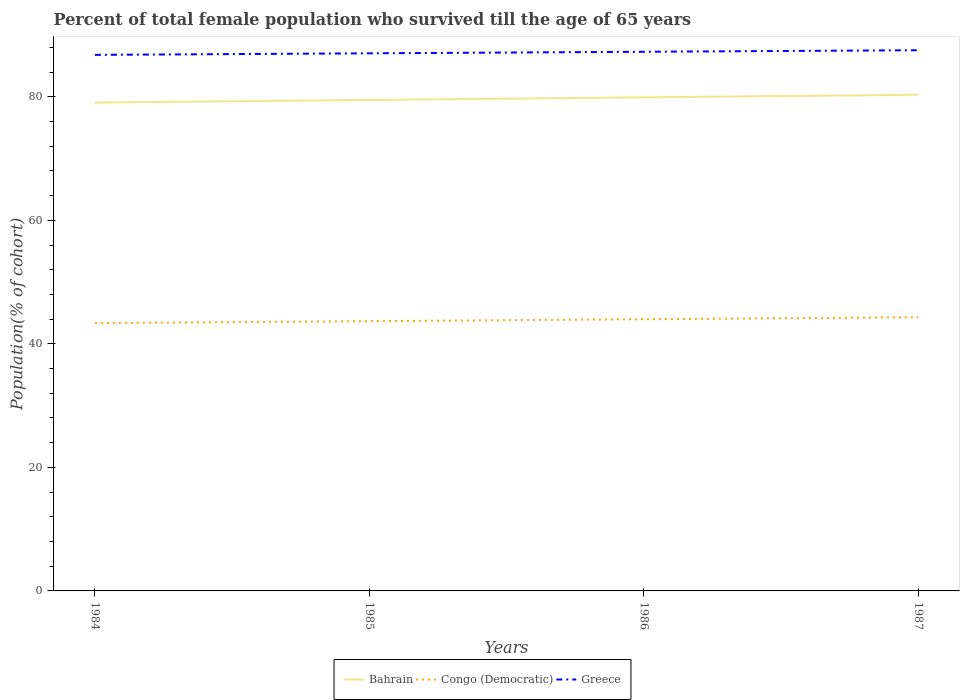How many different coloured lines are there?
Your response must be concise. 3. Is the number of lines equal to the number of legend labels?
Your answer should be very brief. Yes. Across all years, what is the maximum percentage of total female population who survived till the age of 65 years in Congo (Democratic)?
Provide a short and direct response. 43.37. What is the total percentage of total female population who survived till the age of 65 years in Bahrain in the graph?
Your answer should be very brief. -0.85. What is the difference between the highest and the second highest percentage of total female population who survived till the age of 65 years in Bahrain?
Your answer should be compact. 1.27. What is the difference between the highest and the lowest percentage of total female population who survived till the age of 65 years in Bahrain?
Ensure brevity in your answer.  2. What is the difference between two consecutive major ticks on the Y-axis?
Make the answer very short. 20. Does the graph contain any zero values?
Your answer should be compact. No. Where does the legend appear in the graph?
Offer a terse response. Bottom center. What is the title of the graph?
Keep it short and to the point. Percent of total female population who survived till the age of 65 years. What is the label or title of the Y-axis?
Offer a terse response. Population(% of cohort). What is the Population(% of cohort) in Bahrain in 1984?
Your response must be concise. 79.07. What is the Population(% of cohort) in Congo (Democratic) in 1984?
Ensure brevity in your answer.  43.37. What is the Population(% of cohort) in Greece in 1984?
Make the answer very short. 86.8. What is the Population(% of cohort) in Bahrain in 1985?
Offer a very short reply. 79.5. What is the Population(% of cohort) of Congo (Democratic) in 1985?
Your answer should be very brief. 43.68. What is the Population(% of cohort) in Greece in 1985?
Ensure brevity in your answer.  87.05. What is the Population(% of cohort) in Bahrain in 1986?
Your answer should be very brief. 79.92. What is the Population(% of cohort) of Congo (Democratic) in 1986?
Your answer should be compact. 44. What is the Population(% of cohort) of Greece in 1986?
Your response must be concise. 87.3. What is the Population(% of cohort) of Bahrain in 1987?
Offer a terse response. 80.34. What is the Population(% of cohort) in Congo (Democratic) in 1987?
Provide a short and direct response. 44.31. What is the Population(% of cohort) in Greece in 1987?
Your answer should be compact. 87.55. Across all years, what is the maximum Population(% of cohort) in Bahrain?
Give a very brief answer. 80.34. Across all years, what is the maximum Population(% of cohort) in Congo (Democratic)?
Provide a succinct answer. 44.31. Across all years, what is the maximum Population(% of cohort) of Greece?
Offer a terse response. 87.55. Across all years, what is the minimum Population(% of cohort) in Bahrain?
Provide a short and direct response. 79.07. Across all years, what is the minimum Population(% of cohort) of Congo (Democratic)?
Provide a succinct answer. 43.37. Across all years, what is the minimum Population(% of cohort) in Greece?
Your answer should be very brief. 86.8. What is the total Population(% of cohort) of Bahrain in the graph?
Your response must be concise. 318.84. What is the total Population(% of cohort) of Congo (Democratic) in the graph?
Keep it short and to the point. 175.35. What is the total Population(% of cohort) of Greece in the graph?
Your answer should be compact. 348.7. What is the difference between the Population(% of cohort) of Bahrain in 1984 and that in 1985?
Offer a very short reply. -0.42. What is the difference between the Population(% of cohort) of Congo (Democratic) in 1984 and that in 1985?
Your answer should be very brief. -0.32. What is the difference between the Population(% of cohort) of Greece in 1984 and that in 1985?
Provide a short and direct response. -0.25. What is the difference between the Population(% of cohort) in Bahrain in 1984 and that in 1986?
Give a very brief answer. -0.85. What is the difference between the Population(% of cohort) in Congo (Democratic) in 1984 and that in 1986?
Keep it short and to the point. -0.63. What is the difference between the Population(% of cohort) of Greece in 1984 and that in 1986?
Ensure brevity in your answer.  -0.5. What is the difference between the Population(% of cohort) in Bahrain in 1984 and that in 1987?
Keep it short and to the point. -1.27. What is the difference between the Population(% of cohort) in Congo (Democratic) in 1984 and that in 1987?
Keep it short and to the point. -0.95. What is the difference between the Population(% of cohort) in Greece in 1984 and that in 1987?
Your response must be concise. -0.75. What is the difference between the Population(% of cohort) of Bahrain in 1985 and that in 1986?
Make the answer very short. -0.42. What is the difference between the Population(% of cohort) in Congo (Democratic) in 1985 and that in 1986?
Offer a terse response. -0.32. What is the difference between the Population(% of cohort) in Greece in 1985 and that in 1986?
Provide a short and direct response. -0.25. What is the difference between the Population(% of cohort) in Bahrain in 1985 and that in 1987?
Your answer should be very brief. -0.85. What is the difference between the Population(% of cohort) of Congo (Democratic) in 1985 and that in 1987?
Give a very brief answer. -0.63. What is the difference between the Population(% of cohort) in Greece in 1985 and that in 1987?
Provide a succinct answer. -0.5. What is the difference between the Population(% of cohort) of Bahrain in 1986 and that in 1987?
Your response must be concise. -0.42. What is the difference between the Population(% of cohort) in Congo (Democratic) in 1986 and that in 1987?
Provide a succinct answer. -0.32. What is the difference between the Population(% of cohort) of Greece in 1986 and that in 1987?
Provide a succinct answer. -0.25. What is the difference between the Population(% of cohort) of Bahrain in 1984 and the Population(% of cohort) of Congo (Democratic) in 1985?
Give a very brief answer. 35.39. What is the difference between the Population(% of cohort) in Bahrain in 1984 and the Population(% of cohort) in Greece in 1985?
Keep it short and to the point. -7.98. What is the difference between the Population(% of cohort) in Congo (Democratic) in 1984 and the Population(% of cohort) in Greece in 1985?
Your answer should be very brief. -43.69. What is the difference between the Population(% of cohort) of Bahrain in 1984 and the Population(% of cohort) of Congo (Democratic) in 1986?
Your answer should be compact. 35.08. What is the difference between the Population(% of cohort) of Bahrain in 1984 and the Population(% of cohort) of Greece in 1986?
Ensure brevity in your answer.  -8.23. What is the difference between the Population(% of cohort) in Congo (Democratic) in 1984 and the Population(% of cohort) in Greece in 1986?
Make the answer very short. -43.94. What is the difference between the Population(% of cohort) of Bahrain in 1984 and the Population(% of cohort) of Congo (Democratic) in 1987?
Your answer should be very brief. 34.76. What is the difference between the Population(% of cohort) in Bahrain in 1984 and the Population(% of cohort) in Greece in 1987?
Give a very brief answer. -8.48. What is the difference between the Population(% of cohort) in Congo (Democratic) in 1984 and the Population(% of cohort) in Greece in 1987?
Your response must be concise. -44.19. What is the difference between the Population(% of cohort) in Bahrain in 1985 and the Population(% of cohort) in Congo (Democratic) in 1986?
Your response must be concise. 35.5. What is the difference between the Population(% of cohort) of Bahrain in 1985 and the Population(% of cohort) of Greece in 1986?
Ensure brevity in your answer.  -7.8. What is the difference between the Population(% of cohort) in Congo (Democratic) in 1985 and the Population(% of cohort) in Greece in 1986?
Your answer should be very brief. -43.62. What is the difference between the Population(% of cohort) of Bahrain in 1985 and the Population(% of cohort) of Congo (Democratic) in 1987?
Keep it short and to the point. 35.19. What is the difference between the Population(% of cohort) in Bahrain in 1985 and the Population(% of cohort) in Greece in 1987?
Offer a terse response. -8.05. What is the difference between the Population(% of cohort) of Congo (Democratic) in 1985 and the Population(% of cohort) of Greece in 1987?
Keep it short and to the point. -43.87. What is the difference between the Population(% of cohort) in Bahrain in 1986 and the Population(% of cohort) in Congo (Democratic) in 1987?
Make the answer very short. 35.61. What is the difference between the Population(% of cohort) of Bahrain in 1986 and the Population(% of cohort) of Greece in 1987?
Ensure brevity in your answer.  -7.63. What is the difference between the Population(% of cohort) in Congo (Democratic) in 1986 and the Population(% of cohort) in Greece in 1987?
Your response must be concise. -43.56. What is the average Population(% of cohort) in Bahrain per year?
Offer a terse response. 79.71. What is the average Population(% of cohort) of Congo (Democratic) per year?
Offer a very short reply. 43.84. What is the average Population(% of cohort) in Greece per year?
Provide a short and direct response. 87.18. In the year 1984, what is the difference between the Population(% of cohort) of Bahrain and Population(% of cohort) of Congo (Democratic)?
Give a very brief answer. 35.71. In the year 1984, what is the difference between the Population(% of cohort) in Bahrain and Population(% of cohort) in Greece?
Provide a succinct answer. -7.73. In the year 1984, what is the difference between the Population(% of cohort) of Congo (Democratic) and Population(% of cohort) of Greece?
Offer a very short reply. -43.43. In the year 1985, what is the difference between the Population(% of cohort) in Bahrain and Population(% of cohort) in Congo (Democratic)?
Make the answer very short. 35.82. In the year 1985, what is the difference between the Population(% of cohort) in Bahrain and Population(% of cohort) in Greece?
Your answer should be compact. -7.55. In the year 1985, what is the difference between the Population(% of cohort) of Congo (Democratic) and Population(% of cohort) of Greece?
Your answer should be compact. -43.37. In the year 1986, what is the difference between the Population(% of cohort) in Bahrain and Population(% of cohort) in Congo (Democratic)?
Offer a very short reply. 35.93. In the year 1986, what is the difference between the Population(% of cohort) of Bahrain and Population(% of cohort) of Greece?
Your answer should be very brief. -7.38. In the year 1986, what is the difference between the Population(% of cohort) in Congo (Democratic) and Population(% of cohort) in Greece?
Offer a very short reply. -43.31. In the year 1987, what is the difference between the Population(% of cohort) in Bahrain and Population(% of cohort) in Congo (Democratic)?
Your answer should be very brief. 36.03. In the year 1987, what is the difference between the Population(% of cohort) in Bahrain and Population(% of cohort) in Greece?
Offer a very short reply. -7.21. In the year 1987, what is the difference between the Population(% of cohort) in Congo (Democratic) and Population(% of cohort) in Greece?
Give a very brief answer. -43.24. What is the ratio of the Population(% of cohort) of Congo (Democratic) in 1984 to that in 1985?
Offer a very short reply. 0.99. What is the ratio of the Population(% of cohort) in Bahrain in 1984 to that in 1986?
Your response must be concise. 0.99. What is the ratio of the Population(% of cohort) of Congo (Democratic) in 1984 to that in 1986?
Provide a short and direct response. 0.99. What is the ratio of the Population(% of cohort) of Greece in 1984 to that in 1986?
Offer a very short reply. 0.99. What is the ratio of the Population(% of cohort) of Bahrain in 1984 to that in 1987?
Your answer should be compact. 0.98. What is the ratio of the Population(% of cohort) of Congo (Democratic) in 1984 to that in 1987?
Provide a short and direct response. 0.98. What is the ratio of the Population(% of cohort) in Greece in 1984 to that in 1987?
Offer a very short reply. 0.99. What is the ratio of the Population(% of cohort) of Bahrain in 1985 to that in 1986?
Your answer should be very brief. 0.99. What is the ratio of the Population(% of cohort) of Bahrain in 1985 to that in 1987?
Your response must be concise. 0.99. What is the ratio of the Population(% of cohort) of Congo (Democratic) in 1985 to that in 1987?
Make the answer very short. 0.99. What is the ratio of the Population(% of cohort) of Bahrain in 1986 to that in 1987?
Your answer should be compact. 0.99. What is the ratio of the Population(% of cohort) of Congo (Democratic) in 1986 to that in 1987?
Provide a short and direct response. 0.99. What is the difference between the highest and the second highest Population(% of cohort) of Bahrain?
Provide a short and direct response. 0.42. What is the difference between the highest and the second highest Population(% of cohort) in Congo (Democratic)?
Make the answer very short. 0.32. What is the difference between the highest and the second highest Population(% of cohort) of Greece?
Your response must be concise. 0.25. What is the difference between the highest and the lowest Population(% of cohort) of Bahrain?
Give a very brief answer. 1.27. What is the difference between the highest and the lowest Population(% of cohort) of Congo (Democratic)?
Ensure brevity in your answer.  0.95. What is the difference between the highest and the lowest Population(% of cohort) in Greece?
Provide a short and direct response. 0.75. 